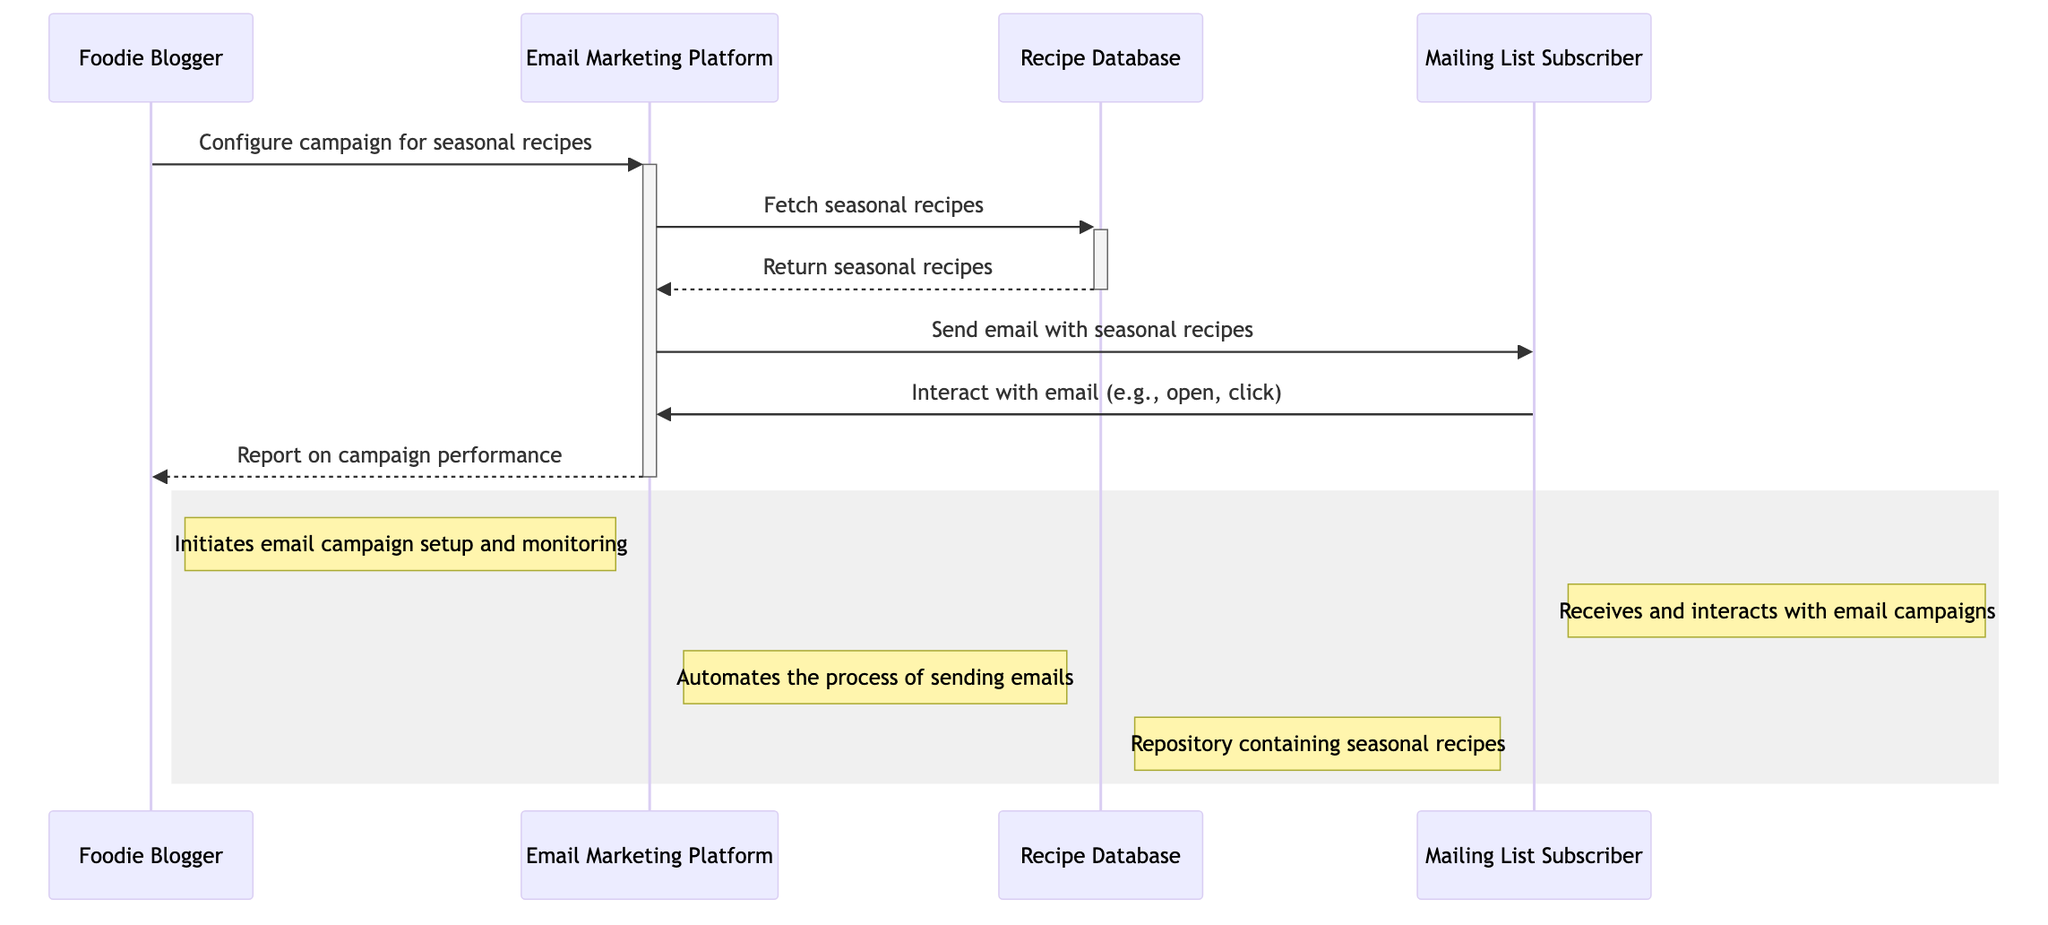What role does the Foodie Blogger play in the campaign? The Foodie Blogger initiates the email campaign setup and monitoring, as indicated by the rectangle in the diagram that describes their actions.
Answer: Initiates email campaign setup and monitoring How many actors are involved in this diagram? The diagram includes four participants: Foodie Blogger, Email Marketing Platform, Recipe Database, and Mailing List Subscriber. Thus, by counting the unique entries, we see there are four actors.
Answer: Four What is the first action taken in the sequence? The first action in the sequence is the Foodie Blogger configuring the campaign for seasonal recipes, which is shown as the initial message in the diagram flow.
Answer: Configure campaign for seasonal recipes Which object is responsible for storing seasonal recipes? The Recipe Database is identified in the diagram as the repository that contains seasonal recipes, as described in the object representation.
Answer: Recipe Database What action occurs immediately after fetching seasonal recipes? After the Email Marketing Platform fetches seasonal recipes from the Recipe Database, the next immediate action is to send an email with those recipes to the Mailing List Subscriber.
Answer: Send email with seasonal recipes Who interacts with the email after it is sent? The Mailing List Subscriber interacts with the email after it is sent. This is denoted by the message flow coming from MLS directed back to the Email Marketing Platform.
Answer: Mailing List Subscriber What is reported to the Foodie Blogger in the end? The Email Marketing Platform reports on campaign performance to the Foodie Blogger at the end of the sequence, highlighting the completion of the feedback loop in the campaign process.
Answer: Report on campaign performance What type of interaction is shown between the Mailing List Subscriber and the Email Marketing Platform? The interaction is represented as "open, click," indicating the kinds of engagements that the Mailing List Subscriber may have with the email, showcasing user interaction.
Answer: Interact with email (e.g., open, click) 